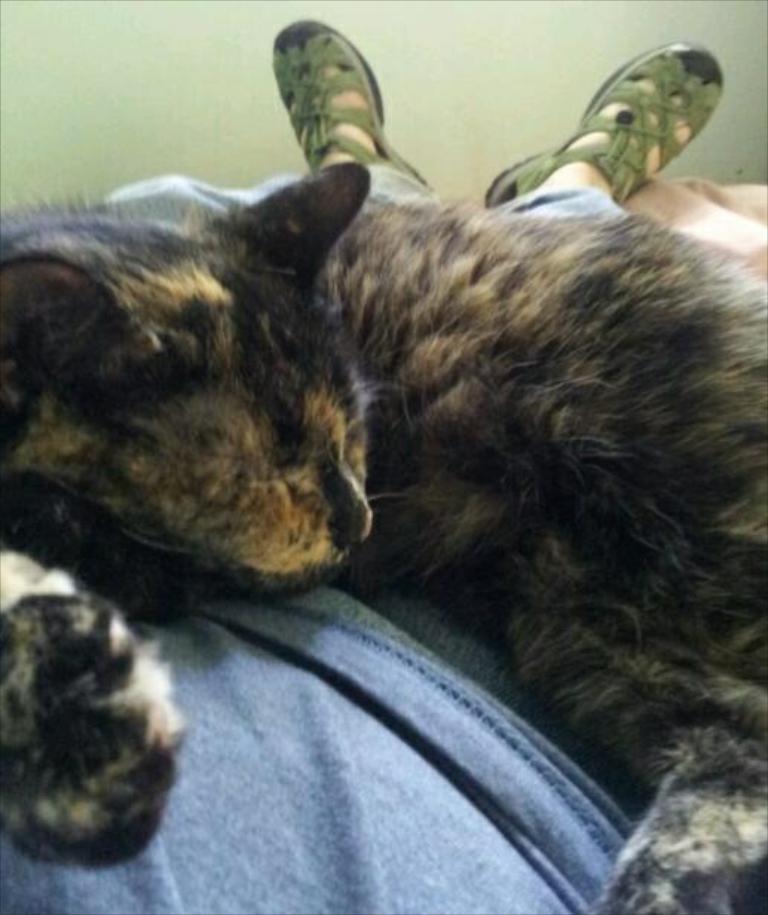In one or two sentences, can you explain what this image depicts? In this picture I can see there is a cat and it is sleeping on the man and he is also lying on the bed. There is a wall in the backdrop. 